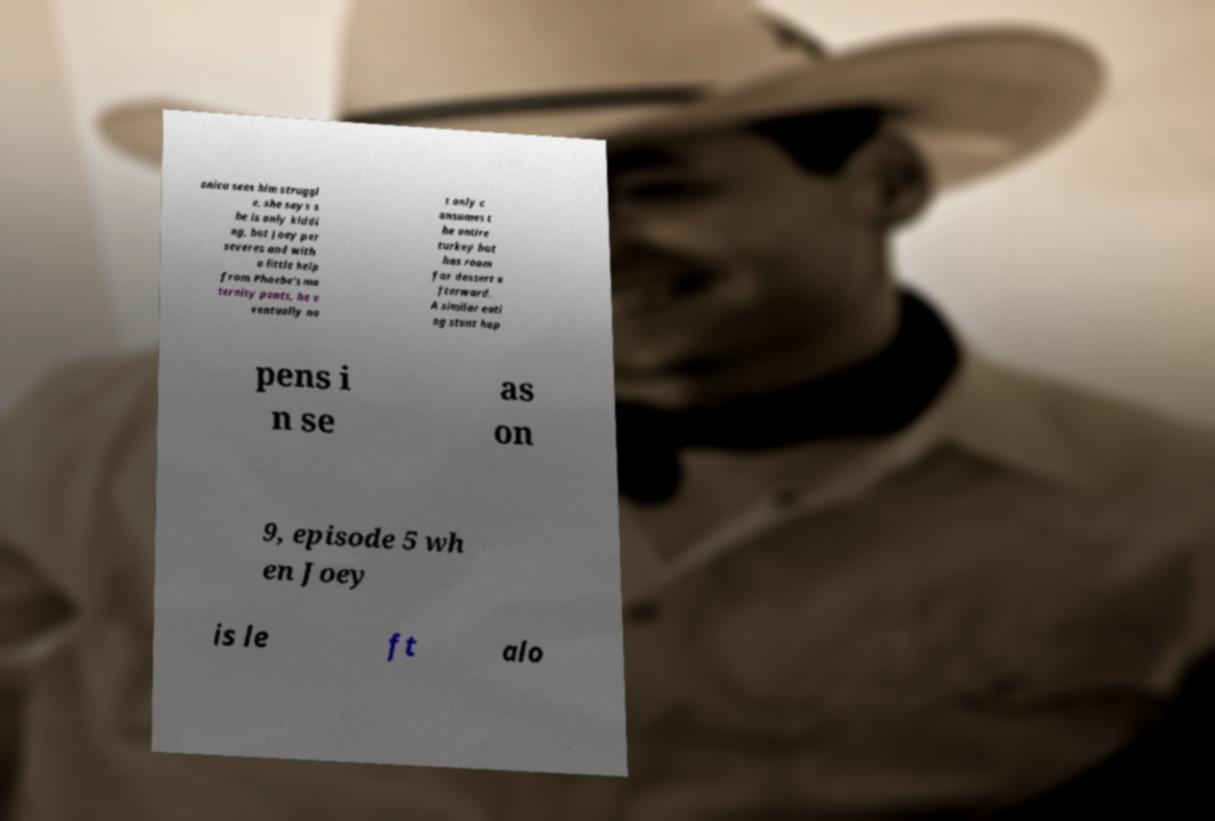For documentation purposes, I need the text within this image transcribed. Could you provide that? onica sees him struggl e, she says s he is only kiddi ng, but Joey per severes and with a little help from Phoebe's ma ternity pants, he e ventually no t only c onsumes t he entire turkey but has room for dessert a fterward. A similar eati ng stunt hap pens i n se as on 9, episode 5 wh en Joey is le ft alo 